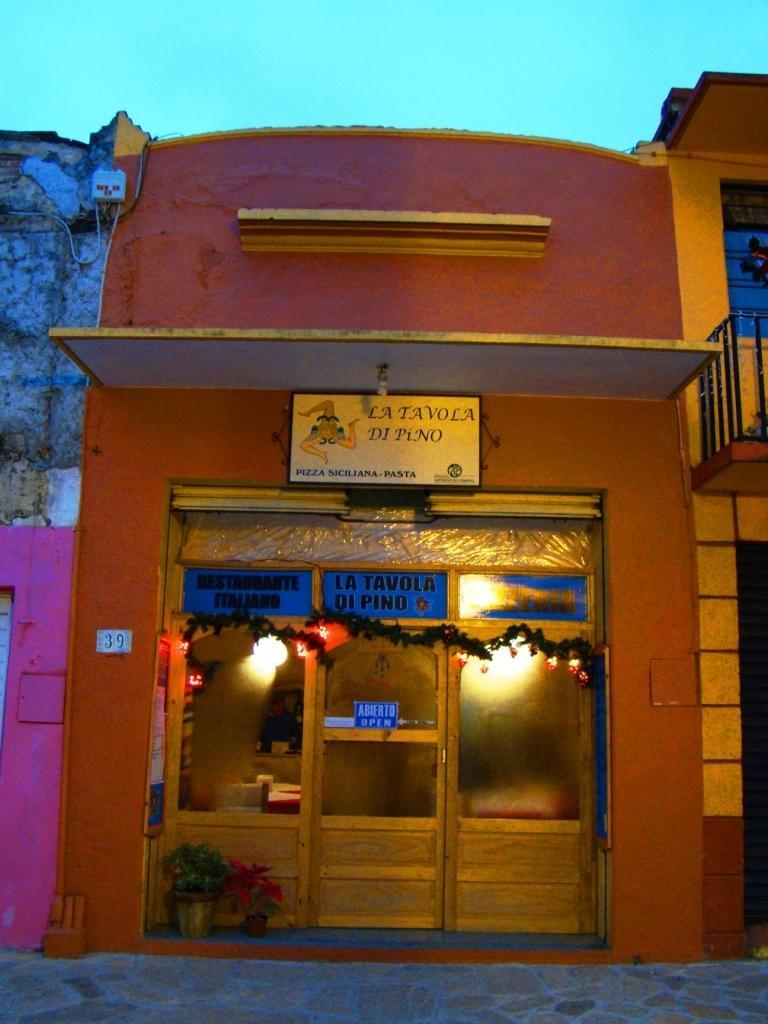Can you describe this image briefly? In this image I can see a building , in front of the building I can see entrance gate and in front of gate I can see flower pots and plants and lights visible in the building. 